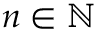<formula> <loc_0><loc_0><loc_500><loc_500>n \in \mathbb { N }</formula> 